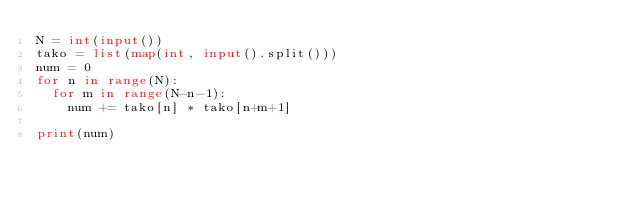<code> <loc_0><loc_0><loc_500><loc_500><_Python_>N = int(input())
tako = list(map(int, input().split()))
num = 0
for n in range(N):
  for m in range(N-n-1):
    num += tako[n] * tako[n+m+1]
      
print(num)

    

</code> 